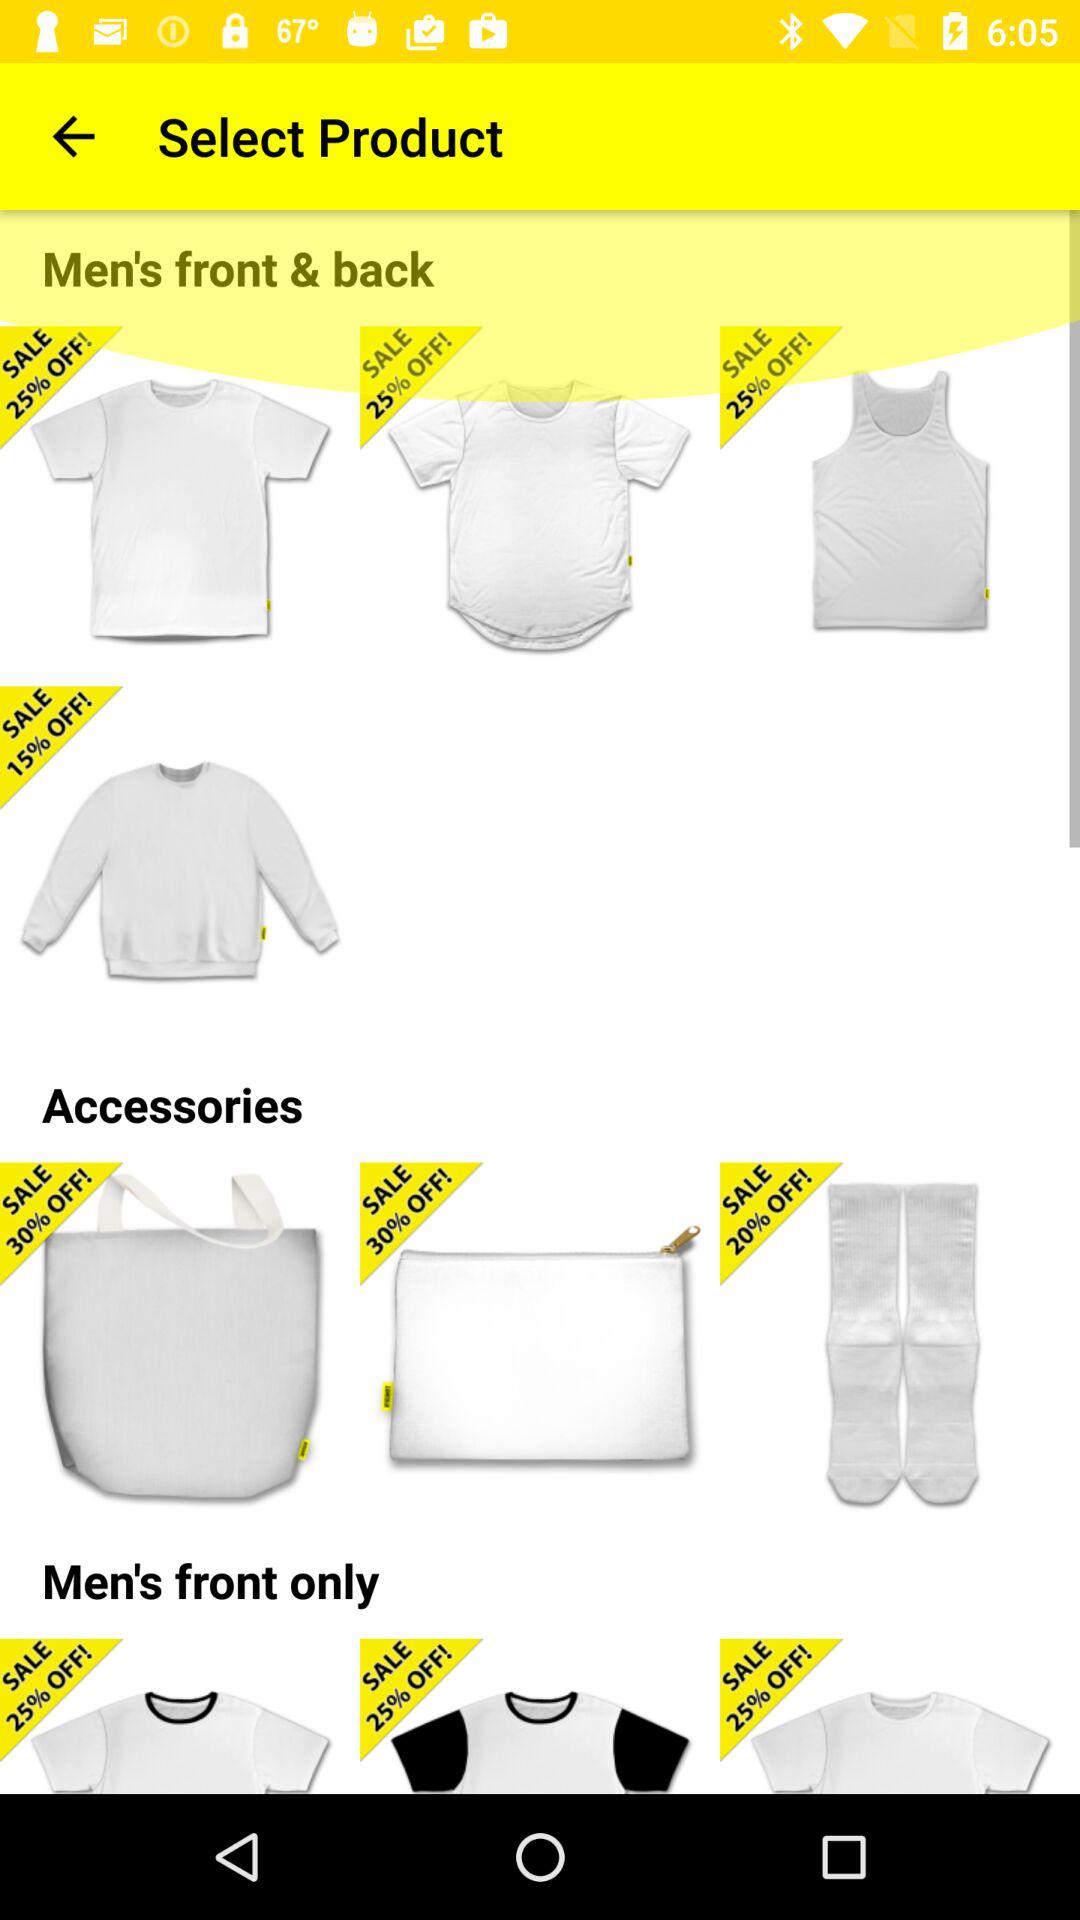How many items are on sale in the Accessories section?
Answer the question using a single word or phrase. 3 